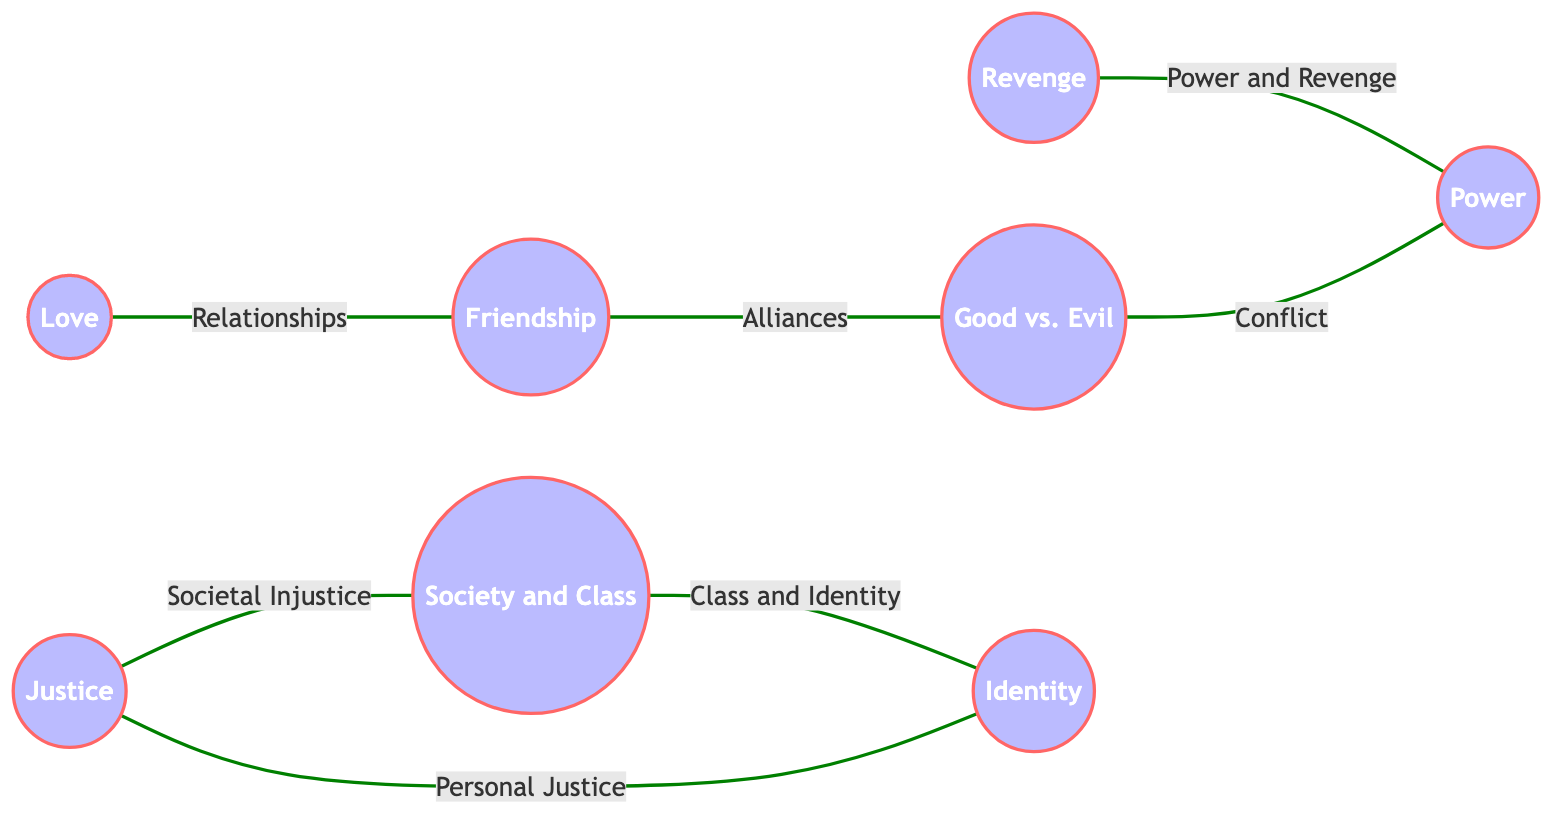What themes are represented by the novel "To Kill a Mockingbird"? The theme represented by "To Kill a Mockingbird" is "Justice". This can be found by looking at the node labeled "Justice" in the diagram, which also lists the novels connected to it.
Answer: Justice How many nodes are there in the diagram? The diagram contains a total of 8 nodes, which represent different literary themes. This can be counted directly from the nodes section of the data provided.
Answer: 8 Which edge represents the relationship between "Revenge" and "Power"? The edge connecting "Revenge" to "Power" is labeled "Power and Revenge". This can be confirmed by examining the edges listed in the data, specifically the one that has "3" (Revenge) pointing to "8" (Power).
Answer: Power and Revenge What is the relationship labeled between "Friendship" and "Good vs. Evil"? There is no direct edge between "Friendship" and "Good vs. Evil" in the diagram, meaning they are not directly connected. This can be affirmed by checking the edges for any connection involving both nodes.
Answer: None How does "Society and Class" relate to "Identity"? "Society and Class" relates to "Identity" through the edge labeled "Class and Identity". This connection is found by referring to the edge connecting node "5" (Society and Class) to node "7" (Identity).
Answer: Class and Identity What is the overall theme that connects "Good vs. Evil" and "Power"? The overall theme that connects "Good vs. Evil" and "Power" is represented by the edge labeled "Conflict". This edge shows a direct relationship between nodes "6" (Good vs. Evil) and "8" (Power).
Answer: Conflict Which two themes are connected by the label "Relationships"? The two themes connected by the label "Relationships" are "Love" and "Friendship". This can be cross-referenced from the edge linking node "2" (Love) to node "4" (Friendship) in the diagram.
Answer: Love and Friendship What theme is connected to "Identity" that leads to "Justice"? The theme connected to "Identity" that leads to "Justice" is "Society and Class", through the label "Class and Identity". This relationship is derived from the edge linking node "7" (Identity) to node "5" (Society and Class), with an eventual connection stemming to node "1" (Justice) through the edge "Societal Injustice".
Answer: Society and Class 